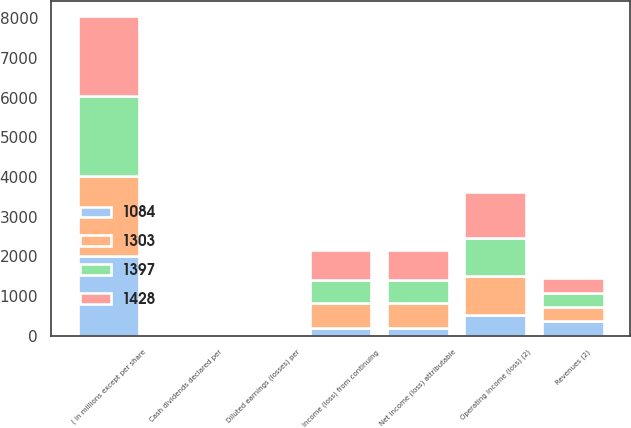Convert chart to OTSL. <chart><loc_0><loc_0><loc_500><loc_500><stacked_bar_chart><ecel><fcel>( in millions except per share<fcel>Revenues (2)<fcel>Operating income (loss) (2)<fcel>Income (loss) from continuing<fcel>Net income (loss) attributable<fcel>Diluted earnings (losses) per<fcel>Cash dividends declared per<nl><fcel>1428<fcel>2014<fcel>362<fcel>1159<fcel>753<fcel>753<fcel>2.54<fcel>0.77<nl><fcel>1303<fcel>2013<fcel>362<fcel>988<fcel>626<fcel>626<fcel>2<fcel>0.64<nl><fcel>1397<fcel>2012<fcel>362<fcel>940<fcel>571<fcel>571<fcel>1.72<fcel>0.49<nl><fcel>1084<fcel>2011<fcel>362<fcel>526<fcel>198<fcel>198<fcel>0.55<fcel>0.39<nl></chart> 